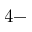Convert formula to latex. <formula><loc_0><loc_0><loc_500><loc_500>4 -</formula> 